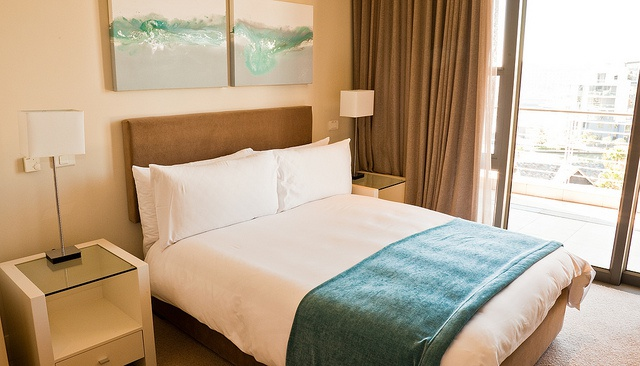Describe the objects in this image and their specific colors. I can see a bed in tan, lightgray, black, and brown tones in this image. 